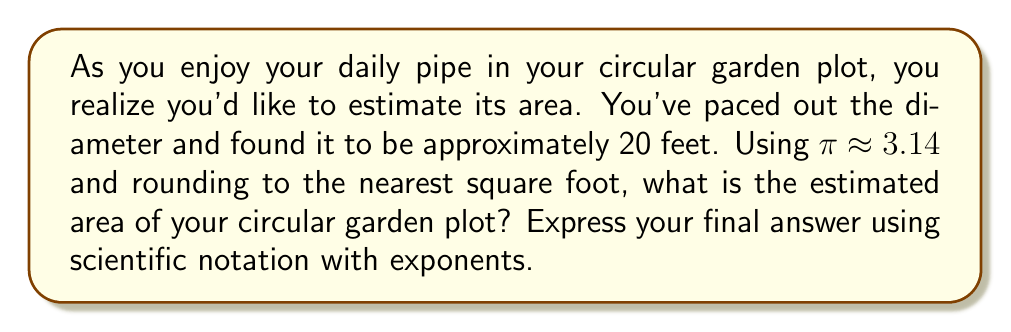Help me with this question. Let's approach this step-by-step:

1) The formula for the area of a circle is:

   $$A = \pi r^2$$

   where $A$ is the area and $r$ is the radius.

2) We're given the diameter, which is 20 feet. The radius is half of this:

   $$r = \frac{20}{2} = 10 \text{ feet}$$

3) Now, let's substitute this into our formula:

   $$A = \pi (10)^2$$

4) Simplify the exponent:

   $$A = \pi (100)$$

5) We're told to use $\pi \approx 3.14$:

   $$A \approx 3.14 (100)$$

6) Multiply:

   $$A \approx 314 \text{ square feet}$$

7) To express this in scientific notation with exponents:

   $$A \approx 3.14 \times 10^2 \text{ square feet}$$

8) Rounding to the nearest square foot doesn't change this result.
Answer: $3.14 \times 10^2 \text{ square feet}$ 